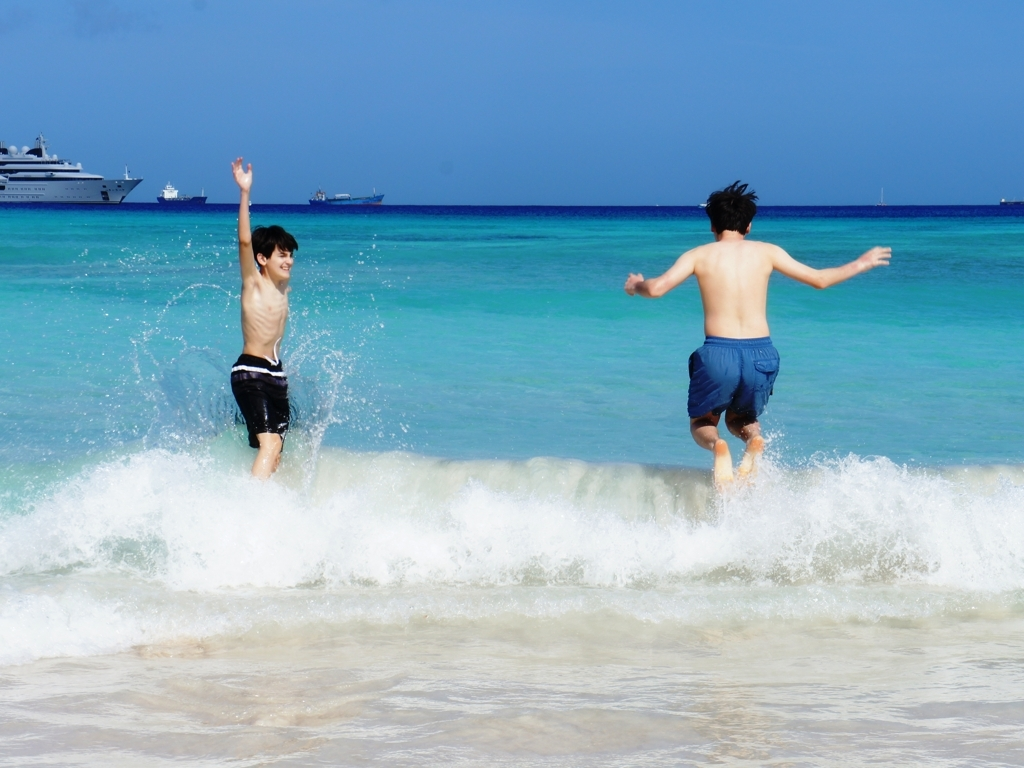What activities are the people in this image engaging in? The individuals appear to be joyfully jumping into a clear, turquoise ocean, which is a common playful activity at the beach, often enjoyed on sunny days. 